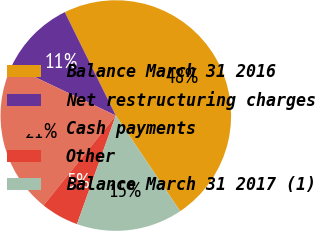Convert chart. <chart><loc_0><loc_0><loc_500><loc_500><pie_chart><fcel>Balance March 31 2016<fcel>Net restructuring charges<fcel>Cash payments<fcel>Other<fcel>Balance March 31 2017 (1)<nl><fcel>47.87%<fcel>10.64%<fcel>21.28%<fcel>5.32%<fcel>14.89%<nl></chart> 